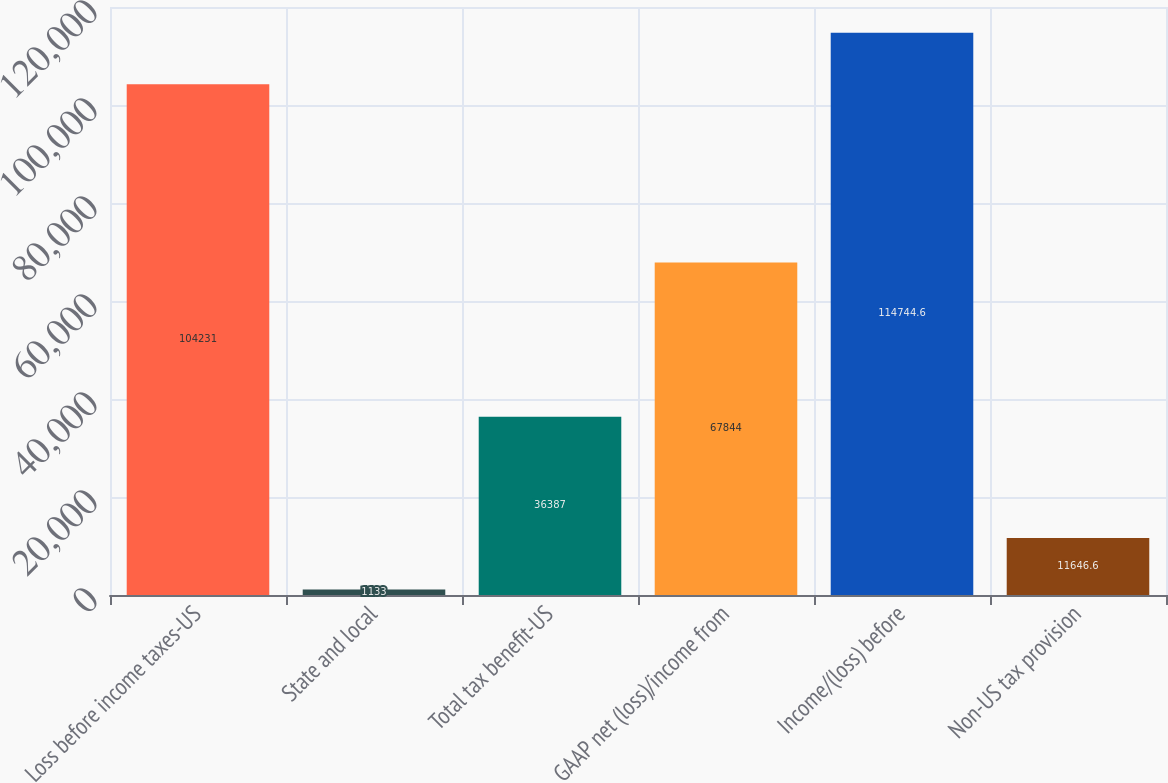Convert chart to OTSL. <chart><loc_0><loc_0><loc_500><loc_500><bar_chart><fcel>Loss before income taxes-US<fcel>State and local<fcel>Total tax benefit-US<fcel>GAAP net (loss)/income from<fcel>Income/(loss) before<fcel>Non-US tax provision<nl><fcel>104231<fcel>1133<fcel>36387<fcel>67844<fcel>114745<fcel>11646.6<nl></chart> 